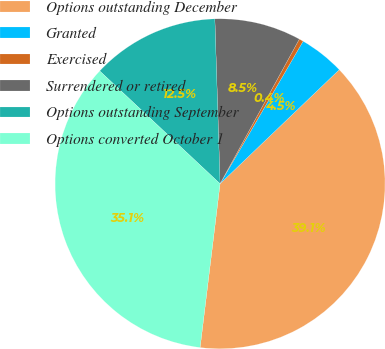Convert chart. <chart><loc_0><loc_0><loc_500><loc_500><pie_chart><fcel>Options outstanding December<fcel>Granted<fcel>Exercised<fcel>Surrendered or retired<fcel>Options outstanding September<fcel>Options converted October 1<nl><fcel>39.08%<fcel>4.45%<fcel>0.42%<fcel>8.48%<fcel>12.51%<fcel>35.05%<nl></chart> 